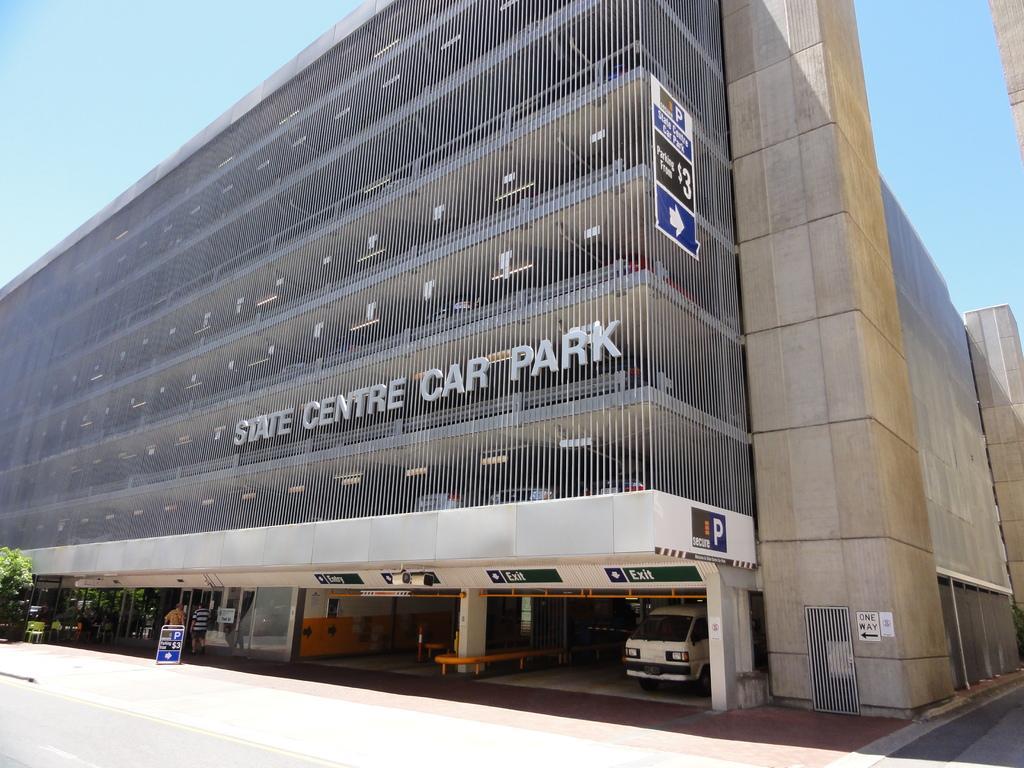Please provide a concise description of this image. In this image I can see the vehicle, few persons walking, trees in green color and the building is in cream color. In the background the sky is in blue color. 